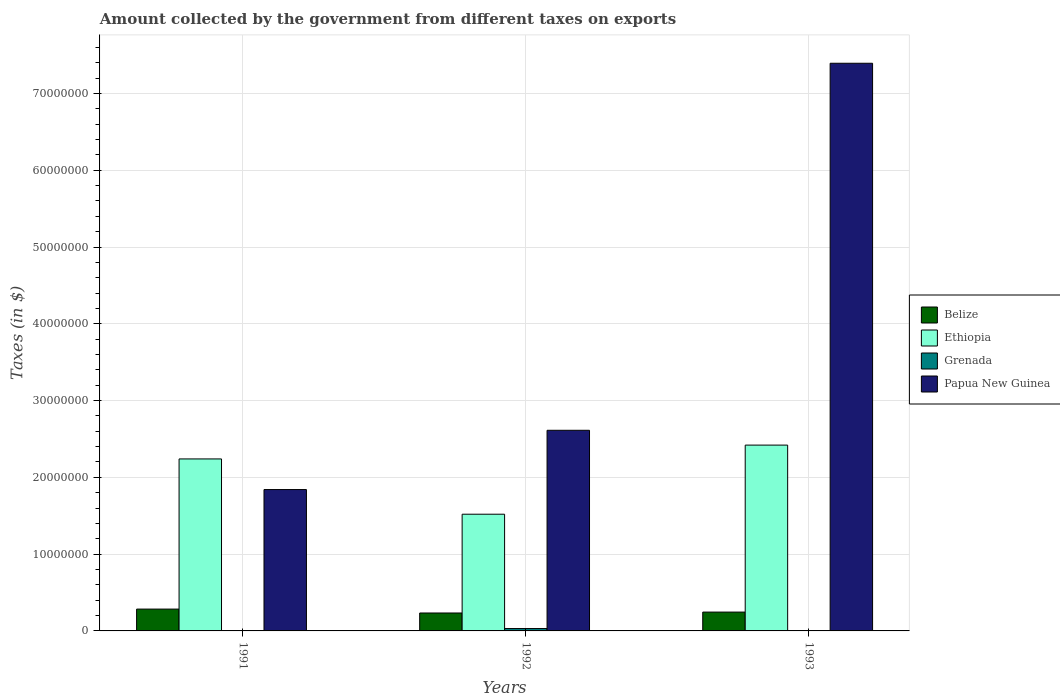How many different coloured bars are there?
Give a very brief answer. 4. How many bars are there on the 2nd tick from the right?
Offer a terse response. 4. In how many cases, is the number of bars for a given year not equal to the number of legend labels?
Your answer should be compact. 0. What is the amount collected by the government from taxes on exports in Belize in 1992?
Give a very brief answer. 2.34e+06. Across all years, what is the maximum amount collected by the government from taxes on exports in Ethiopia?
Provide a succinct answer. 2.42e+07. Across all years, what is the minimum amount collected by the government from taxes on exports in Papua New Guinea?
Offer a terse response. 1.84e+07. What is the difference between the amount collected by the government from taxes on exports in Papua New Guinea in 1992 and that in 1993?
Ensure brevity in your answer.  -4.78e+07. What is the difference between the amount collected by the government from taxes on exports in Belize in 1993 and the amount collected by the government from taxes on exports in Papua New Guinea in 1991?
Give a very brief answer. -1.60e+07. What is the average amount collected by the government from taxes on exports in Grenada per year?
Make the answer very short. 1.10e+05. In the year 1991, what is the difference between the amount collected by the government from taxes on exports in Ethiopia and amount collected by the government from taxes on exports in Belize?
Provide a short and direct response. 1.96e+07. What is the ratio of the amount collected by the government from taxes on exports in Belize in 1991 to that in 1993?
Make the answer very short. 1.16. What is the difference between the highest and the second highest amount collected by the government from taxes on exports in Belize?
Provide a short and direct response. 3.90e+05. What is the difference between the highest and the lowest amount collected by the government from taxes on exports in Ethiopia?
Keep it short and to the point. 9.00e+06. In how many years, is the amount collected by the government from taxes on exports in Ethiopia greater than the average amount collected by the government from taxes on exports in Ethiopia taken over all years?
Offer a very short reply. 2. Is it the case that in every year, the sum of the amount collected by the government from taxes on exports in Grenada and amount collected by the government from taxes on exports in Belize is greater than the sum of amount collected by the government from taxes on exports in Papua New Guinea and amount collected by the government from taxes on exports in Ethiopia?
Your answer should be very brief. No. What does the 4th bar from the left in 1991 represents?
Offer a very short reply. Papua New Guinea. What does the 3rd bar from the right in 1993 represents?
Your answer should be compact. Ethiopia. Is it the case that in every year, the sum of the amount collected by the government from taxes on exports in Belize and amount collected by the government from taxes on exports in Papua New Guinea is greater than the amount collected by the government from taxes on exports in Grenada?
Your answer should be very brief. Yes. How many bars are there?
Ensure brevity in your answer.  12. Are all the bars in the graph horizontal?
Offer a very short reply. No. How many years are there in the graph?
Your answer should be very brief. 3. Are the values on the major ticks of Y-axis written in scientific E-notation?
Provide a short and direct response. No. Does the graph contain any zero values?
Your answer should be compact. No. Does the graph contain grids?
Make the answer very short. Yes. How many legend labels are there?
Keep it short and to the point. 4. How are the legend labels stacked?
Your response must be concise. Vertical. What is the title of the graph?
Give a very brief answer. Amount collected by the government from different taxes on exports. What is the label or title of the X-axis?
Provide a short and direct response. Years. What is the label or title of the Y-axis?
Offer a very short reply. Taxes (in $). What is the Taxes (in $) of Belize in 1991?
Keep it short and to the point. 2.84e+06. What is the Taxes (in $) of Ethiopia in 1991?
Make the answer very short. 2.24e+07. What is the Taxes (in $) in Papua New Guinea in 1991?
Give a very brief answer. 1.84e+07. What is the Taxes (in $) of Belize in 1992?
Your response must be concise. 2.34e+06. What is the Taxes (in $) in Ethiopia in 1992?
Your answer should be very brief. 1.52e+07. What is the Taxes (in $) of Grenada in 1992?
Your answer should be compact. 3.10e+05. What is the Taxes (in $) in Papua New Guinea in 1992?
Your answer should be compact. 2.61e+07. What is the Taxes (in $) of Belize in 1993?
Provide a succinct answer. 2.45e+06. What is the Taxes (in $) in Ethiopia in 1993?
Your answer should be very brief. 2.42e+07. What is the Taxes (in $) in Grenada in 1993?
Give a very brief answer. 10000. What is the Taxes (in $) of Papua New Guinea in 1993?
Your response must be concise. 7.39e+07. Across all years, what is the maximum Taxes (in $) in Belize?
Your response must be concise. 2.84e+06. Across all years, what is the maximum Taxes (in $) of Ethiopia?
Ensure brevity in your answer.  2.42e+07. Across all years, what is the maximum Taxes (in $) in Papua New Guinea?
Ensure brevity in your answer.  7.39e+07. Across all years, what is the minimum Taxes (in $) in Belize?
Make the answer very short. 2.34e+06. Across all years, what is the minimum Taxes (in $) in Ethiopia?
Your answer should be compact. 1.52e+07. Across all years, what is the minimum Taxes (in $) of Papua New Guinea?
Make the answer very short. 1.84e+07. What is the total Taxes (in $) in Belize in the graph?
Give a very brief answer. 7.63e+06. What is the total Taxes (in $) of Ethiopia in the graph?
Your response must be concise. 6.18e+07. What is the total Taxes (in $) in Grenada in the graph?
Your response must be concise. 3.30e+05. What is the total Taxes (in $) of Papua New Guinea in the graph?
Ensure brevity in your answer.  1.18e+08. What is the difference between the Taxes (in $) in Belize in 1991 and that in 1992?
Provide a short and direct response. 5.07e+05. What is the difference between the Taxes (in $) of Ethiopia in 1991 and that in 1992?
Ensure brevity in your answer.  7.20e+06. What is the difference between the Taxes (in $) of Papua New Guinea in 1991 and that in 1992?
Keep it short and to the point. -7.72e+06. What is the difference between the Taxes (in $) of Ethiopia in 1991 and that in 1993?
Your answer should be compact. -1.80e+06. What is the difference between the Taxes (in $) in Grenada in 1991 and that in 1993?
Provide a succinct answer. 0. What is the difference between the Taxes (in $) of Papua New Guinea in 1991 and that in 1993?
Your answer should be compact. -5.55e+07. What is the difference between the Taxes (in $) of Belize in 1992 and that in 1993?
Provide a succinct answer. -1.17e+05. What is the difference between the Taxes (in $) in Ethiopia in 1992 and that in 1993?
Your answer should be compact. -9.00e+06. What is the difference between the Taxes (in $) in Papua New Guinea in 1992 and that in 1993?
Provide a succinct answer. -4.78e+07. What is the difference between the Taxes (in $) of Belize in 1991 and the Taxes (in $) of Ethiopia in 1992?
Your answer should be compact. -1.24e+07. What is the difference between the Taxes (in $) of Belize in 1991 and the Taxes (in $) of Grenada in 1992?
Offer a very short reply. 2.53e+06. What is the difference between the Taxes (in $) of Belize in 1991 and the Taxes (in $) of Papua New Guinea in 1992?
Make the answer very short. -2.33e+07. What is the difference between the Taxes (in $) of Ethiopia in 1991 and the Taxes (in $) of Grenada in 1992?
Ensure brevity in your answer.  2.21e+07. What is the difference between the Taxes (in $) in Ethiopia in 1991 and the Taxes (in $) in Papua New Guinea in 1992?
Offer a terse response. -3.73e+06. What is the difference between the Taxes (in $) of Grenada in 1991 and the Taxes (in $) of Papua New Guinea in 1992?
Offer a terse response. -2.61e+07. What is the difference between the Taxes (in $) of Belize in 1991 and the Taxes (in $) of Ethiopia in 1993?
Offer a terse response. -2.14e+07. What is the difference between the Taxes (in $) in Belize in 1991 and the Taxes (in $) in Grenada in 1993?
Offer a very short reply. 2.83e+06. What is the difference between the Taxes (in $) in Belize in 1991 and the Taxes (in $) in Papua New Guinea in 1993?
Offer a very short reply. -7.11e+07. What is the difference between the Taxes (in $) of Ethiopia in 1991 and the Taxes (in $) of Grenada in 1993?
Give a very brief answer. 2.24e+07. What is the difference between the Taxes (in $) of Ethiopia in 1991 and the Taxes (in $) of Papua New Guinea in 1993?
Offer a terse response. -5.15e+07. What is the difference between the Taxes (in $) in Grenada in 1991 and the Taxes (in $) in Papua New Guinea in 1993?
Your answer should be very brief. -7.39e+07. What is the difference between the Taxes (in $) in Belize in 1992 and the Taxes (in $) in Ethiopia in 1993?
Your response must be concise. -2.19e+07. What is the difference between the Taxes (in $) of Belize in 1992 and the Taxes (in $) of Grenada in 1993?
Keep it short and to the point. 2.33e+06. What is the difference between the Taxes (in $) of Belize in 1992 and the Taxes (in $) of Papua New Guinea in 1993?
Make the answer very short. -7.16e+07. What is the difference between the Taxes (in $) in Ethiopia in 1992 and the Taxes (in $) in Grenada in 1993?
Give a very brief answer. 1.52e+07. What is the difference between the Taxes (in $) in Ethiopia in 1992 and the Taxes (in $) in Papua New Guinea in 1993?
Offer a terse response. -5.87e+07. What is the difference between the Taxes (in $) in Grenada in 1992 and the Taxes (in $) in Papua New Guinea in 1993?
Your response must be concise. -7.36e+07. What is the average Taxes (in $) in Belize per year?
Offer a terse response. 2.54e+06. What is the average Taxes (in $) in Ethiopia per year?
Offer a terse response. 2.06e+07. What is the average Taxes (in $) of Grenada per year?
Keep it short and to the point. 1.10e+05. What is the average Taxes (in $) in Papua New Guinea per year?
Ensure brevity in your answer.  3.95e+07. In the year 1991, what is the difference between the Taxes (in $) in Belize and Taxes (in $) in Ethiopia?
Your answer should be very brief. -1.96e+07. In the year 1991, what is the difference between the Taxes (in $) in Belize and Taxes (in $) in Grenada?
Make the answer very short. 2.83e+06. In the year 1991, what is the difference between the Taxes (in $) in Belize and Taxes (in $) in Papua New Guinea?
Offer a terse response. -1.56e+07. In the year 1991, what is the difference between the Taxes (in $) of Ethiopia and Taxes (in $) of Grenada?
Ensure brevity in your answer.  2.24e+07. In the year 1991, what is the difference between the Taxes (in $) of Ethiopia and Taxes (in $) of Papua New Guinea?
Your answer should be compact. 3.99e+06. In the year 1991, what is the difference between the Taxes (in $) in Grenada and Taxes (in $) in Papua New Guinea?
Ensure brevity in your answer.  -1.84e+07. In the year 1992, what is the difference between the Taxes (in $) in Belize and Taxes (in $) in Ethiopia?
Offer a terse response. -1.29e+07. In the year 1992, what is the difference between the Taxes (in $) in Belize and Taxes (in $) in Grenada?
Make the answer very short. 2.03e+06. In the year 1992, what is the difference between the Taxes (in $) in Belize and Taxes (in $) in Papua New Guinea?
Offer a terse response. -2.38e+07. In the year 1992, what is the difference between the Taxes (in $) of Ethiopia and Taxes (in $) of Grenada?
Provide a succinct answer. 1.49e+07. In the year 1992, what is the difference between the Taxes (in $) of Ethiopia and Taxes (in $) of Papua New Guinea?
Keep it short and to the point. -1.09e+07. In the year 1992, what is the difference between the Taxes (in $) in Grenada and Taxes (in $) in Papua New Guinea?
Give a very brief answer. -2.58e+07. In the year 1993, what is the difference between the Taxes (in $) in Belize and Taxes (in $) in Ethiopia?
Make the answer very short. -2.17e+07. In the year 1993, what is the difference between the Taxes (in $) of Belize and Taxes (in $) of Grenada?
Keep it short and to the point. 2.44e+06. In the year 1993, what is the difference between the Taxes (in $) in Belize and Taxes (in $) in Papua New Guinea?
Offer a very short reply. -7.15e+07. In the year 1993, what is the difference between the Taxes (in $) of Ethiopia and Taxes (in $) of Grenada?
Your answer should be compact. 2.42e+07. In the year 1993, what is the difference between the Taxes (in $) of Ethiopia and Taxes (in $) of Papua New Guinea?
Give a very brief answer. -4.97e+07. In the year 1993, what is the difference between the Taxes (in $) in Grenada and Taxes (in $) in Papua New Guinea?
Keep it short and to the point. -7.39e+07. What is the ratio of the Taxes (in $) in Belize in 1991 to that in 1992?
Keep it short and to the point. 1.22. What is the ratio of the Taxes (in $) of Ethiopia in 1991 to that in 1992?
Your answer should be very brief. 1.47. What is the ratio of the Taxes (in $) in Grenada in 1991 to that in 1992?
Offer a terse response. 0.03. What is the ratio of the Taxes (in $) in Papua New Guinea in 1991 to that in 1992?
Keep it short and to the point. 0.7. What is the ratio of the Taxes (in $) in Belize in 1991 to that in 1993?
Provide a short and direct response. 1.16. What is the ratio of the Taxes (in $) of Ethiopia in 1991 to that in 1993?
Provide a short and direct response. 0.93. What is the ratio of the Taxes (in $) of Grenada in 1991 to that in 1993?
Your response must be concise. 1. What is the ratio of the Taxes (in $) of Papua New Guinea in 1991 to that in 1993?
Provide a succinct answer. 0.25. What is the ratio of the Taxes (in $) of Belize in 1992 to that in 1993?
Make the answer very short. 0.95. What is the ratio of the Taxes (in $) of Ethiopia in 1992 to that in 1993?
Give a very brief answer. 0.63. What is the ratio of the Taxes (in $) of Grenada in 1992 to that in 1993?
Give a very brief answer. 31. What is the ratio of the Taxes (in $) in Papua New Guinea in 1992 to that in 1993?
Provide a short and direct response. 0.35. What is the difference between the highest and the second highest Taxes (in $) in Belize?
Ensure brevity in your answer.  3.90e+05. What is the difference between the highest and the second highest Taxes (in $) in Ethiopia?
Your answer should be compact. 1.80e+06. What is the difference between the highest and the second highest Taxes (in $) of Grenada?
Provide a short and direct response. 3.00e+05. What is the difference between the highest and the second highest Taxes (in $) in Papua New Guinea?
Offer a very short reply. 4.78e+07. What is the difference between the highest and the lowest Taxes (in $) of Belize?
Make the answer very short. 5.07e+05. What is the difference between the highest and the lowest Taxes (in $) in Ethiopia?
Provide a succinct answer. 9.00e+06. What is the difference between the highest and the lowest Taxes (in $) in Papua New Guinea?
Provide a succinct answer. 5.55e+07. 